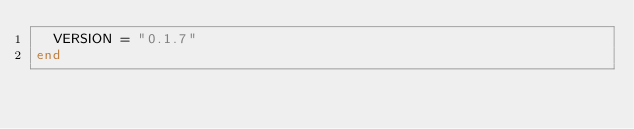Convert code to text. <code><loc_0><loc_0><loc_500><loc_500><_Ruby_>  VERSION = "0.1.7"
end
</code> 